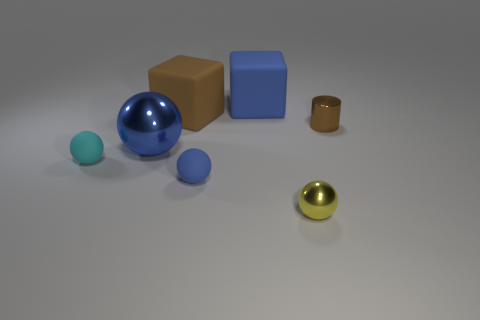There is a thing that is behind the brown rubber block; how many metal balls are on the left side of it? I can see two metal balls to the left of the brown rubber block in the image, one of which is significantly smaller than the other. 